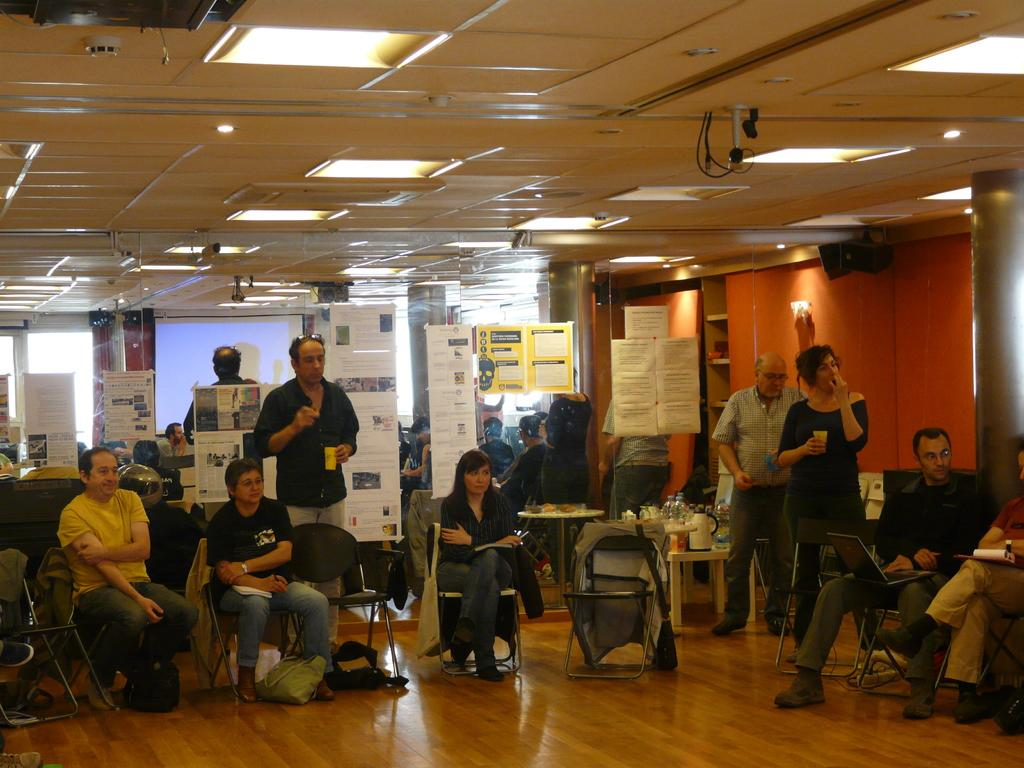What are the people in the image doing? There are people sitting on chairs and people standing in the image. Can you describe the positions of the people in the image? Some people are sitting on chairs, while others are standing. What direction are the goldfish swimming in the image? There are no goldfish present in the image. Can you tell me how fast the people are running in the image? There is no indication that the people are running in the image; they are either sitting or standing. 